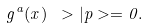Convert formula to latex. <formula><loc_0><loc_0><loc_500><loc_500>g ^ { a } ( x ) \ > | p > = 0 .</formula> 